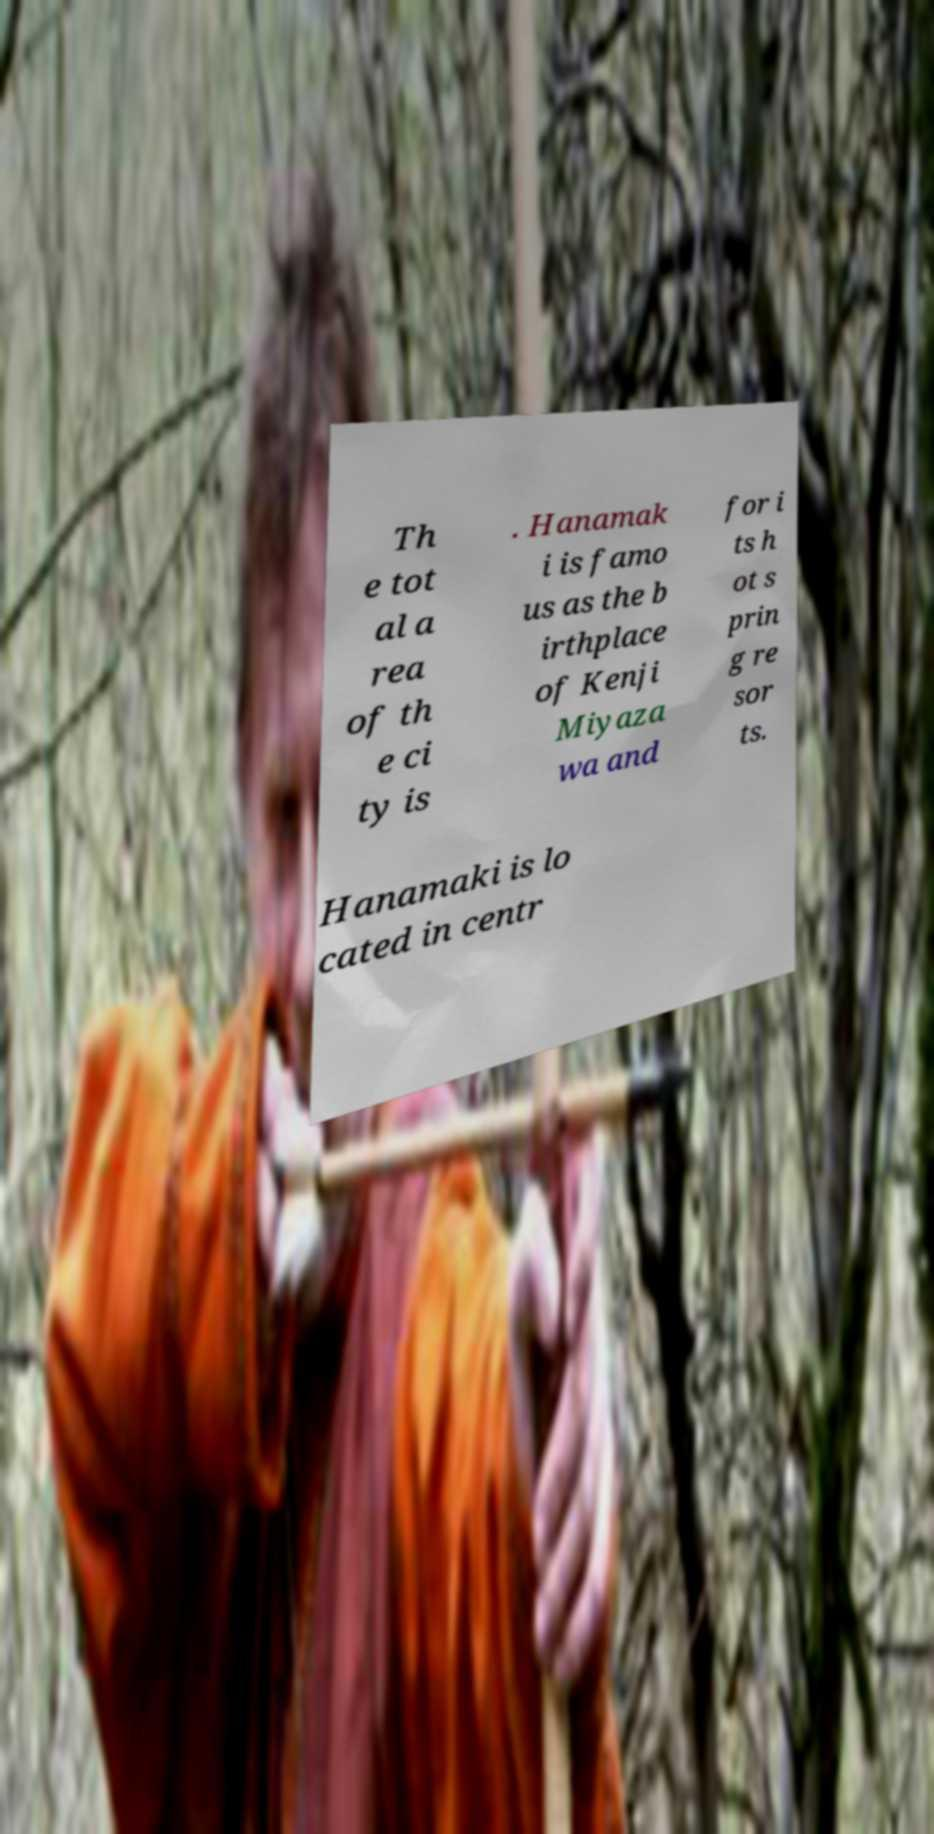For documentation purposes, I need the text within this image transcribed. Could you provide that? Th e tot al a rea of th e ci ty is . Hanamak i is famo us as the b irthplace of Kenji Miyaza wa and for i ts h ot s prin g re sor ts. Hanamaki is lo cated in centr 